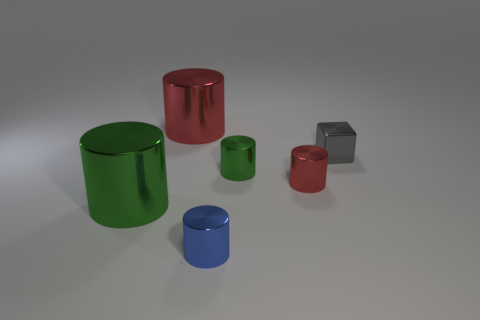Subtract all blue cylinders. How many cylinders are left? 4 Subtract all small red metal cylinders. How many cylinders are left? 4 Add 3 tiny gray cubes. How many objects exist? 9 Subtract all purple cylinders. Subtract all red blocks. How many cylinders are left? 5 Subtract all cylinders. How many objects are left? 1 Add 1 small blue metal objects. How many small blue metal objects exist? 2 Subtract 0 brown spheres. How many objects are left? 6 Subtract all big red shiny objects. Subtract all small metallic cylinders. How many objects are left? 2 Add 3 large red things. How many large red things are left? 4 